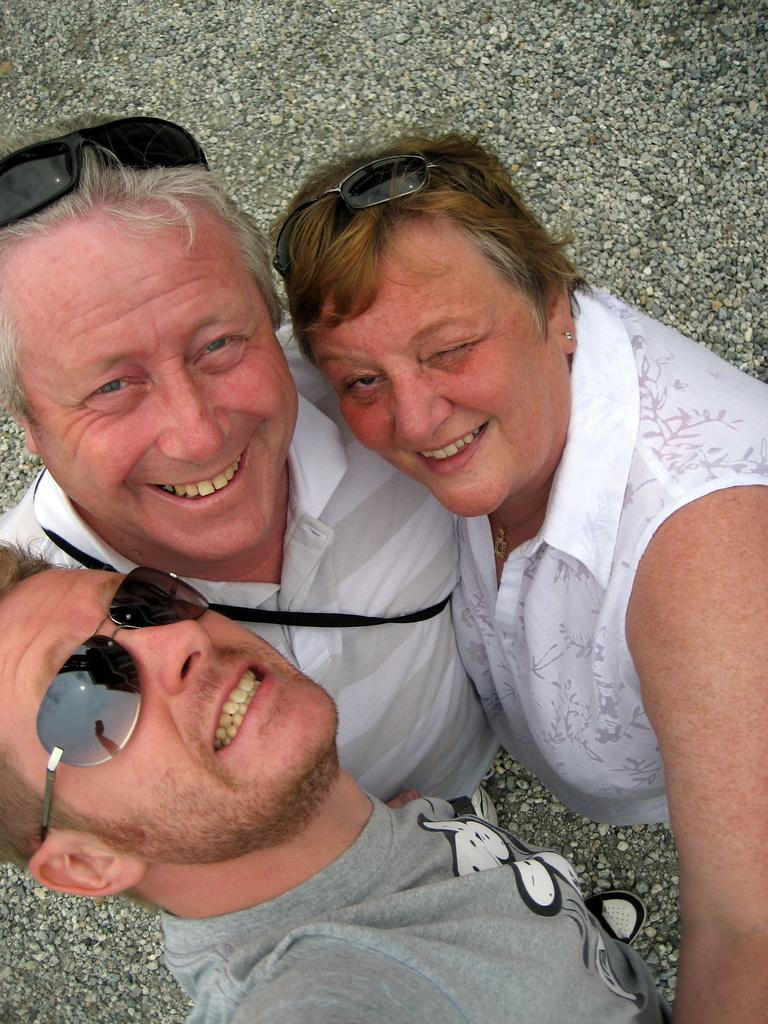How many people are in the image? There are three people in the image. What are the people doing in the image? The people are standing in the image. What expressions do the people have in the image? The people are smiling in the image. What type of natural elements can be seen in the image? There are stones visible in the image. What type of soap is being used to clean the square in the image? There is no soap or square present in the image. 